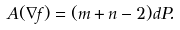<formula> <loc_0><loc_0><loc_500><loc_500>A ( \nabla f ) = ( m + n - 2 ) d P .</formula> 